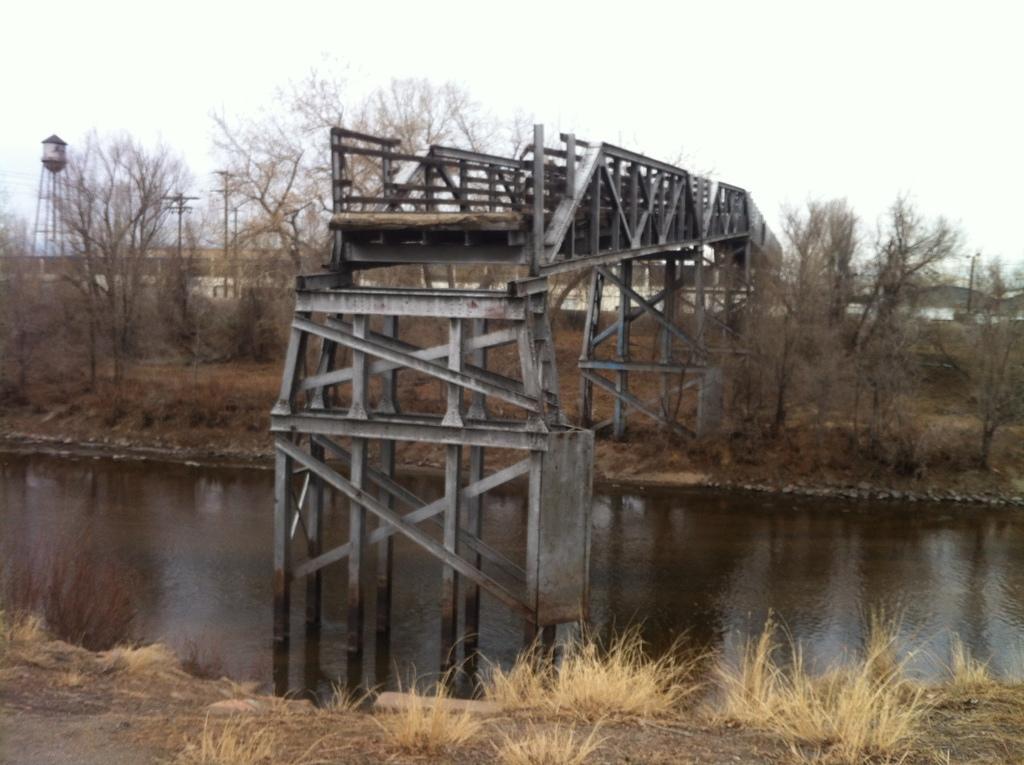Please provide a concise description of this image. We can see grass, water, trees and bridge. In the background we can see poles, tower, buildings and sky. 